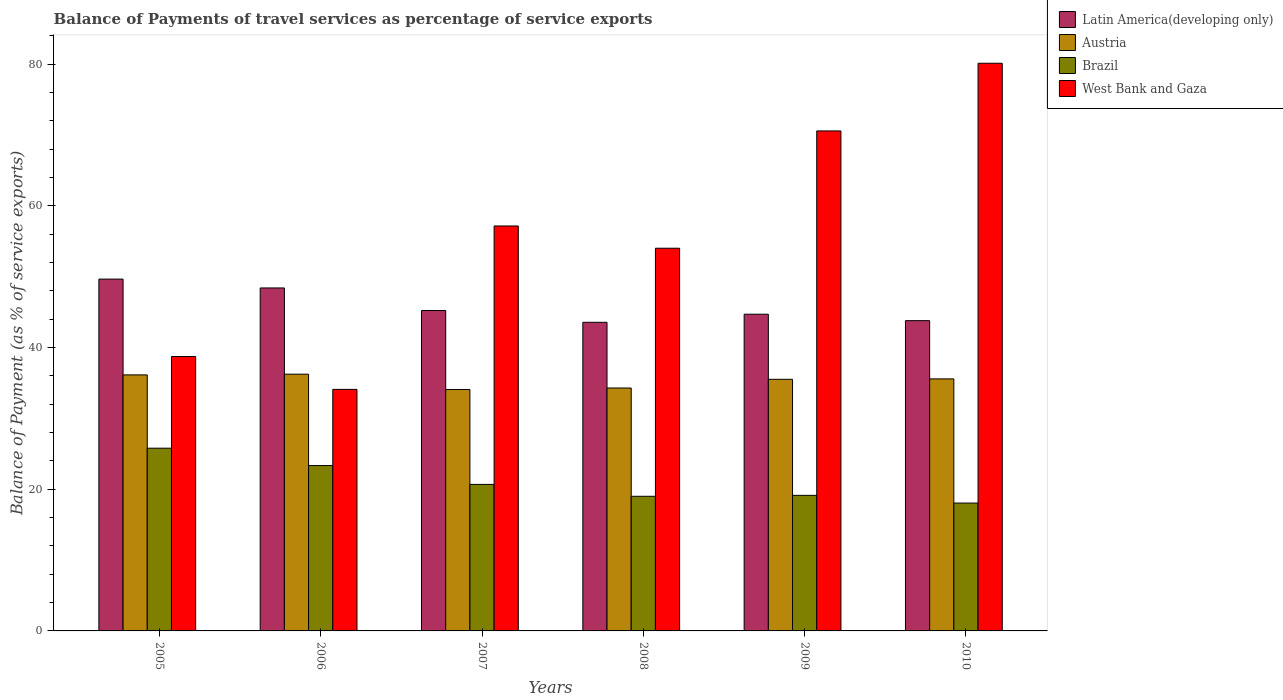How many different coloured bars are there?
Ensure brevity in your answer.  4. How many groups of bars are there?
Keep it short and to the point. 6. How many bars are there on the 3rd tick from the left?
Your response must be concise. 4. How many bars are there on the 5th tick from the right?
Keep it short and to the point. 4. What is the balance of payments of travel services in West Bank and Gaza in 2009?
Offer a terse response. 70.56. Across all years, what is the maximum balance of payments of travel services in Brazil?
Make the answer very short. 25.78. Across all years, what is the minimum balance of payments of travel services in Brazil?
Your answer should be very brief. 18.04. In which year was the balance of payments of travel services in Austria maximum?
Give a very brief answer. 2006. What is the total balance of payments of travel services in Austria in the graph?
Provide a short and direct response. 211.78. What is the difference between the balance of payments of travel services in Latin America(developing only) in 2006 and that in 2010?
Give a very brief answer. 4.61. What is the difference between the balance of payments of travel services in West Bank and Gaza in 2007 and the balance of payments of travel services in Brazil in 2010?
Provide a succinct answer. 39.1. What is the average balance of payments of travel services in West Bank and Gaza per year?
Ensure brevity in your answer.  55.77. In the year 2006, what is the difference between the balance of payments of travel services in West Bank and Gaza and balance of payments of travel services in Austria?
Offer a very short reply. -2.14. What is the ratio of the balance of payments of travel services in Latin America(developing only) in 2005 to that in 2010?
Your answer should be compact. 1.13. Is the balance of payments of travel services in Brazil in 2006 less than that in 2008?
Make the answer very short. No. Is the difference between the balance of payments of travel services in West Bank and Gaza in 2008 and 2009 greater than the difference between the balance of payments of travel services in Austria in 2008 and 2009?
Your response must be concise. No. What is the difference between the highest and the second highest balance of payments of travel services in Brazil?
Provide a short and direct response. 2.45. What is the difference between the highest and the lowest balance of payments of travel services in Austria?
Your answer should be compact. 2.16. What does the 3rd bar from the left in 2010 represents?
Offer a terse response. Brazil. What does the 1st bar from the right in 2007 represents?
Provide a succinct answer. West Bank and Gaza. Is it the case that in every year, the sum of the balance of payments of travel services in Latin America(developing only) and balance of payments of travel services in Brazil is greater than the balance of payments of travel services in West Bank and Gaza?
Give a very brief answer. No. How many bars are there?
Keep it short and to the point. 24. Are all the bars in the graph horizontal?
Offer a very short reply. No. How many years are there in the graph?
Offer a very short reply. 6. Are the values on the major ticks of Y-axis written in scientific E-notation?
Make the answer very short. No. Does the graph contain any zero values?
Provide a succinct answer. No. Does the graph contain grids?
Give a very brief answer. No. Where does the legend appear in the graph?
Your answer should be very brief. Top right. How many legend labels are there?
Provide a short and direct response. 4. How are the legend labels stacked?
Provide a succinct answer. Vertical. What is the title of the graph?
Provide a short and direct response. Balance of Payments of travel services as percentage of service exports. What is the label or title of the X-axis?
Provide a short and direct response. Years. What is the label or title of the Y-axis?
Your answer should be very brief. Balance of Payment (as % of service exports). What is the Balance of Payment (as % of service exports) of Latin America(developing only) in 2005?
Give a very brief answer. 49.65. What is the Balance of Payment (as % of service exports) in Austria in 2005?
Give a very brief answer. 36.13. What is the Balance of Payment (as % of service exports) in Brazil in 2005?
Ensure brevity in your answer.  25.78. What is the Balance of Payment (as % of service exports) in West Bank and Gaza in 2005?
Your answer should be very brief. 38.72. What is the Balance of Payment (as % of service exports) in Latin America(developing only) in 2006?
Provide a short and direct response. 48.4. What is the Balance of Payment (as % of service exports) of Austria in 2006?
Offer a very short reply. 36.23. What is the Balance of Payment (as % of service exports) of Brazil in 2006?
Provide a succinct answer. 23.34. What is the Balance of Payment (as % of service exports) of West Bank and Gaza in 2006?
Offer a terse response. 34.09. What is the Balance of Payment (as % of service exports) in Latin America(developing only) in 2007?
Provide a short and direct response. 45.22. What is the Balance of Payment (as % of service exports) in Austria in 2007?
Provide a short and direct response. 34.07. What is the Balance of Payment (as % of service exports) in Brazil in 2007?
Ensure brevity in your answer.  20.68. What is the Balance of Payment (as % of service exports) of West Bank and Gaza in 2007?
Ensure brevity in your answer.  57.14. What is the Balance of Payment (as % of service exports) of Latin America(developing only) in 2008?
Offer a very short reply. 43.55. What is the Balance of Payment (as % of service exports) in Austria in 2008?
Offer a terse response. 34.28. What is the Balance of Payment (as % of service exports) of Brazil in 2008?
Your answer should be compact. 19. What is the Balance of Payment (as % of service exports) of West Bank and Gaza in 2008?
Make the answer very short. 54. What is the Balance of Payment (as % of service exports) in Latin America(developing only) in 2009?
Ensure brevity in your answer.  44.69. What is the Balance of Payment (as % of service exports) of Austria in 2009?
Offer a terse response. 35.51. What is the Balance of Payment (as % of service exports) in Brazil in 2009?
Provide a succinct answer. 19.13. What is the Balance of Payment (as % of service exports) in West Bank and Gaza in 2009?
Offer a terse response. 70.56. What is the Balance of Payment (as % of service exports) of Latin America(developing only) in 2010?
Provide a succinct answer. 43.78. What is the Balance of Payment (as % of service exports) of Austria in 2010?
Your answer should be compact. 35.57. What is the Balance of Payment (as % of service exports) in Brazil in 2010?
Keep it short and to the point. 18.04. What is the Balance of Payment (as % of service exports) in West Bank and Gaza in 2010?
Keep it short and to the point. 80.1. Across all years, what is the maximum Balance of Payment (as % of service exports) in Latin America(developing only)?
Make the answer very short. 49.65. Across all years, what is the maximum Balance of Payment (as % of service exports) of Austria?
Your answer should be compact. 36.23. Across all years, what is the maximum Balance of Payment (as % of service exports) of Brazil?
Your answer should be very brief. 25.78. Across all years, what is the maximum Balance of Payment (as % of service exports) of West Bank and Gaza?
Ensure brevity in your answer.  80.1. Across all years, what is the minimum Balance of Payment (as % of service exports) in Latin America(developing only)?
Provide a short and direct response. 43.55. Across all years, what is the minimum Balance of Payment (as % of service exports) of Austria?
Your response must be concise. 34.07. Across all years, what is the minimum Balance of Payment (as % of service exports) in Brazil?
Your answer should be very brief. 18.04. Across all years, what is the minimum Balance of Payment (as % of service exports) in West Bank and Gaza?
Keep it short and to the point. 34.09. What is the total Balance of Payment (as % of service exports) of Latin America(developing only) in the graph?
Your answer should be very brief. 275.29. What is the total Balance of Payment (as % of service exports) in Austria in the graph?
Provide a short and direct response. 211.78. What is the total Balance of Payment (as % of service exports) in Brazil in the graph?
Give a very brief answer. 125.97. What is the total Balance of Payment (as % of service exports) of West Bank and Gaza in the graph?
Make the answer very short. 334.61. What is the difference between the Balance of Payment (as % of service exports) of Latin America(developing only) in 2005 and that in 2006?
Provide a succinct answer. 1.25. What is the difference between the Balance of Payment (as % of service exports) of Austria in 2005 and that in 2006?
Keep it short and to the point. -0.1. What is the difference between the Balance of Payment (as % of service exports) in Brazil in 2005 and that in 2006?
Provide a succinct answer. 2.45. What is the difference between the Balance of Payment (as % of service exports) of West Bank and Gaza in 2005 and that in 2006?
Keep it short and to the point. 4.63. What is the difference between the Balance of Payment (as % of service exports) in Latin America(developing only) in 2005 and that in 2007?
Ensure brevity in your answer.  4.43. What is the difference between the Balance of Payment (as % of service exports) in Austria in 2005 and that in 2007?
Provide a succinct answer. 2.06. What is the difference between the Balance of Payment (as % of service exports) in Brazil in 2005 and that in 2007?
Your response must be concise. 5.11. What is the difference between the Balance of Payment (as % of service exports) in West Bank and Gaza in 2005 and that in 2007?
Your response must be concise. -18.43. What is the difference between the Balance of Payment (as % of service exports) of Latin America(developing only) in 2005 and that in 2008?
Keep it short and to the point. 6.1. What is the difference between the Balance of Payment (as % of service exports) of Austria in 2005 and that in 2008?
Keep it short and to the point. 1.85. What is the difference between the Balance of Payment (as % of service exports) in Brazil in 2005 and that in 2008?
Give a very brief answer. 6.79. What is the difference between the Balance of Payment (as % of service exports) of West Bank and Gaza in 2005 and that in 2008?
Offer a terse response. -15.29. What is the difference between the Balance of Payment (as % of service exports) of Latin America(developing only) in 2005 and that in 2009?
Ensure brevity in your answer.  4.96. What is the difference between the Balance of Payment (as % of service exports) in Austria in 2005 and that in 2009?
Offer a very short reply. 0.62. What is the difference between the Balance of Payment (as % of service exports) in Brazil in 2005 and that in 2009?
Keep it short and to the point. 6.65. What is the difference between the Balance of Payment (as % of service exports) in West Bank and Gaza in 2005 and that in 2009?
Give a very brief answer. -31.84. What is the difference between the Balance of Payment (as % of service exports) of Latin America(developing only) in 2005 and that in 2010?
Offer a terse response. 5.86. What is the difference between the Balance of Payment (as % of service exports) in Austria in 2005 and that in 2010?
Your response must be concise. 0.56. What is the difference between the Balance of Payment (as % of service exports) in Brazil in 2005 and that in 2010?
Keep it short and to the point. 7.74. What is the difference between the Balance of Payment (as % of service exports) of West Bank and Gaza in 2005 and that in 2010?
Offer a very short reply. -41.39. What is the difference between the Balance of Payment (as % of service exports) in Latin America(developing only) in 2006 and that in 2007?
Ensure brevity in your answer.  3.18. What is the difference between the Balance of Payment (as % of service exports) of Austria in 2006 and that in 2007?
Provide a short and direct response. 2.16. What is the difference between the Balance of Payment (as % of service exports) of Brazil in 2006 and that in 2007?
Your answer should be compact. 2.66. What is the difference between the Balance of Payment (as % of service exports) of West Bank and Gaza in 2006 and that in 2007?
Your answer should be very brief. -23.06. What is the difference between the Balance of Payment (as % of service exports) in Latin America(developing only) in 2006 and that in 2008?
Your answer should be compact. 4.85. What is the difference between the Balance of Payment (as % of service exports) in Austria in 2006 and that in 2008?
Give a very brief answer. 1.95. What is the difference between the Balance of Payment (as % of service exports) of Brazil in 2006 and that in 2008?
Offer a very short reply. 4.34. What is the difference between the Balance of Payment (as % of service exports) in West Bank and Gaza in 2006 and that in 2008?
Make the answer very short. -19.92. What is the difference between the Balance of Payment (as % of service exports) in Latin America(developing only) in 2006 and that in 2009?
Provide a succinct answer. 3.71. What is the difference between the Balance of Payment (as % of service exports) of Austria in 2006 and that in 2009?
Make the answer very short. 0.72. What is the difference between the Balance of Payment (as % of service exports) in Brazil in 2006 and that in 2009?
Offer a terse response. 4.2. What is the difference between the Balance of Payment (as % of service exports) in West Bank and Gaza in 2006 and that in 2009?
Your response must be concise. -36.47. What is the difference between the Balance of Payment (as % of service exports) of Latin America(developing only) in 2006 and that in 2010?
Your answer should be very brief. 4.61. What is the difference between the Balance of Payment (as % of service exports) of Austria in 2006 and that in 2010?
Give a very brief answer. 0.66. What is the difference between the Balance of Payment (as % of service exports) in Brazil in 2006 and that in 2010?
Provide a short and direct response. 5.29. What is the difference between the Balance of Payment (as % of service exports) in West Bank and Gaza in 2006 and that in 2010?
Provide a short and direct response. -46.02. What is the difference between the Balance of Payment (as % of service exports) in Latin America(developing only) in 2007 and that in 2008?
Provide a short and direct response. 1.67. What is the difference between the Balance of Payment (as % of service exports) in Austria in 2007 and that in 2008?
Provide a short and direct response. -0.21. What is the difference between the Balance of Payment (as % of service exports) in Brazil in 2007 and that in 2008?
Your response must be concise. 1.68. What is the difference between the Balance of Payment (as % of service exports) in West Bank and Gaza in 2007 and that in 2008?
Provide a short and direct response. 3.14. What is the difference between the Balance of Payment (as % of service exports) in Latin America(developing only) in 2007 and that in 2009?
Your response must be concise. 0.53. What is the difference between the Balance of Payment (as % of service exports) in Austria in 2007 and that in 2009?
Provide a short and direct response. -1.44. What is the difference between the Balance of Payment (as % of service exports) in Brazil in 2007 and that in 2009?
Make the answer very short. 1.55. What is the difference between the Balance of Payment (as % of service exports) in West Bank and Gaza in 2007 and that in 2009?
Your response must be concise. -13.41. What is the difference between the Balance of Payment (as % of service exports) of Latin America(developing only) in 2007 and that in 2010?
Keep it short and to the point. 1.43. What is the difference between the Balance of Payment (as % of service exports) in Austria in 2007 and that in 2010?
Your answer should be compact. -1.5. What is the difference between the Balance of Payment (as % of service exports) of Brazil in 2007 and that in 2010?
Offer a terse response. 2.63. What is the difference between the Balance of Payment (as % of service exports) in West Bank and Gaza in 2007 and that in 2010?
Offer a very short reply. -22.96. What is the difference between the Balance of Payment (as % of service exports) in Latin America(developing only) in 2008 and that in 2009?
Your answer should be very brief. -1.14. What is the difference between the Balance of Payment (as % of service exports) in Austria in 2008 and that in 2009?
Make the answer very short. -1.23. What is the difference between the Balance of Payment (as % of service exports) of Brazil in 2008 and that in 2009?
Give a very brief answer. -0.13. What is the difference between the Balance of Payment (as % of service exports) in West Bank and Gaza in 2008 and that in 2009?
Offer a very short reply. -16.55. What is the difference between the Balance of Payment (as % of service exports) of Latin America(developing only) in 2008 and that in 2010?
Keep it short and to the point. -0.23. What is the difference between the Balance of Payment (as % of service exports) of Austria in 2008 and that in 2010?
Offer a terse response. -1.29. What is the difference between the Balance of Payment (as % of service exports) in Brazil in 2008 and that in 2010?
Provide a short and direct response. 0.95. What is the difference between the Balance of Payment (as % of service exports) of West Bank and Gaza in 2008 and that in 2010?
Ensure brevity in your answer.  -26.1. What is the difference between the Balance of Payment (as % of service exports) of Latin America(developing only) in 2009 and that in 2010?
Offer a very short reply. 0.91. What is the difference between the Balance of Payment (as % of service exports) in Austria in 2009 and that in 2010?
Your answer should be compact. -0.06. What is the difference between the Balance of Payment (as % of service exports) in Brazil in 2009 and that in 2010?
Your response must be concise. 1.09. What is the difference between the Balance of Payment (as % of service exports) in West Bank and Gaza in 2009 and that in 2010?
Your answer should be very brief. -9.55. What is the difference between the Balance of Payment (as % of service exports) in Latin America(developing only) in 2005 and the Balance of Payment (as % of service exports) in Austria in 2006?
Give a very brief answer. 13.42. What is the difference between the Balance of Payment (as % of service exports) in Latin America(developing only) in 2005 and the Balance of Payment (as % of service exports) in Brazil in 2006?
Provide a short and direct response. 26.31. What is the difference between the Balance of Payment (as % of service exports) of Latin America(developing only) in 2005 and the Balance of Payment (as % of service exports) of West Bank and Gaza in 2006?
Keep it short and to the point. 15.56. What is the difference between the Balance of Payment (as % of service exports) of Austria in 2005 and the Balance of Payment (as % of service exports) of Brazil in 2006?
Give a very brief answer. 12.79. What is the difference between the Balance of Payment (as % of service exports) in Austria in 2005 and the Balance of Payment (as % of service exports) in West Bank and Gaza in 2006?
Provide a succinct answer. 2.04. What is the difference between the Balance of Payment (as % of service exports) of Brazil in 2005 and the Balance of Payment (as % of service exports) of West Bank and Gaza in 2006?
Offer a terse response. -8.3. What is the difference between the Balance of Payment (as % of service exports) in Latin America(developing only) in 2005 and the Balance of Payment (as % of service exports) in Austria in 2007?
Keep it short and to the point. 15.58. What is the difference between the Balance of Payment (as % of service exports) in Latin America(developing only) in 2005 and the Balance of Payment (as % of service exports) in Brazil in 2007?
Ensure brevity in your answer.  28.97. What is the difference between the Balance of Payment (as % of service exports) of Latin America(developing only) in 2005 and the Balance of Payment (as % of service exports) of West Bank and Gaza in 2007?
Ensure brevity in your answer.  -7.5. What is the difference between the Balance of Payment (as % of service exports) in Austria in 2005 and the Balance of Payment (as % of service exports) in Brazil in 2007?
Keep it short and to the point. 15.45. What is the difference between the Balance of Payment (as % of service exports) of Austria in 2005 and the Balance of Payment (as % of service exports) of West Bank and Gaza in 2007?
Give a very brief answer. -21.02. What is the difference between the Balance of Payment (as % of service exports) in Brazil in 2005 and the Balance of Payment (as % of service exports) in West Bank and Gaza in 2007?
Your response must be concise. -31.36. What is the difference between the Balance of Payment (as % of service exports) of Latin America(developing only) in 2005 and the Balance of Payment (as % of service exports) of Austria in 2008?
Give a very brief answer. 15.37. What is the difference between the Balance of Payment (as % of service exports) of Latin America(developing only) in 2005 and the Balance of Payment (as % of service exports) of Brazil in 2008?
Your response must be concise. 30.65. What is the difference between the Balance of Payment (as % of service exports) in Latin America(developing only) in 2005 and the Balance of Payment (as % of service exports) in West Bank and Gaza in 2008?
Make the answer very short. -4.36. What is the difference between the Balance of Payment (as % of service exports) of Austria in 2005 and the Balance of Payment (as % of service exports) of Brazil in 2008?
Make the answer very short. 17.13. What is the difference between the Balance of Payment (as % of service exports) of Austria in 2005 and the Balance of Payment (as % of service exports) of West Bank and Gaza in 2008?
Ensure brevity in your answer.  -17.87. What is the difference between the Balance of Payment (as % of service exports) in Brazil in 2005 and the Balance of Payment (as % of service exports) in West Bank and Gaza in 2008?
Give a very brief answer. -28.22. What is the difference between the Balance of Payment (as % of service exports) in Latin America(developing only) in 2005 and the Balance of Payment (as % of service exports) in Austria in 2009?
Make the answer very short. 14.14. What is the difference between the Balance of Payment (as % of service exports) in Latin America(developing only) in 2005 and the Balance of Payment (as % of service exports) in Brazil in 2009?
Provide a short and direct response. 30.52. What is the difference between the Balance of Payment (as % of service exports) of Latin America(developing only) in 2005 and the Balance of Payment (as % of service exports) of West Bank and Gaza in 2009?
Give a very brief answer. -20.91. What is the difference between the Balance of Payment (as % of service exports) of Austria in 2005 and the Balance of Payment (as % of service exports) of Brazil in 2009?
Keep it short and to the point. 17. What is the difference between the Balance of Payment (as % of service exports) of Austria in 2005 and the Balance of Payment (as % of service exports) of West Bank and Gaza in 2009?
Provide a succinct answer. -34.43. What is the difference between the Balance of Payment (as % of service exports) of Brazil in 2005 and the Balance of Payment (as % of service exports) of West Bank and Gaza in 2009?
Ensure brevity in your answer.  -44.77. What is the difference between the Balance of Payment (as % of service exports) of Latin America(developing only) in 2005 and the Balance of Payment (as % of service exports) of Austria in 2010?
Your answer should be very brief. 14.08. What is the difference between the Balance of Payment (as % of service exports) in Latin America(developing only) in 2005 and the Balance of Payment (as % of service exports) in Brazil in 2010?
Ensure brevity in your answer.  31.6. What is the difference between the Balance of Payment (as % of service exports) of Latin America(developing only) in 2005 and the Balance of Payment (as % of service exports) of West Bank and Gaza in 2010?
Offer a very short reply. -30.46. What is the difference between the Balance of Payment (as % of service exports) in Austria in 2005 and the Balance of Payment (as % of service exports) in Brazil in 2010?
Provide a short and direct response. 18.08. What is the difference between the Balance of Payment (as % of service exports) in Austria in 2005 and the Balance of Payment (as % of service exports) in West Bank and Gaza in 2010?
Offer a very short reply. -43.98. What is the difference between the Balance of Payment (as % of service exports) in Brazil in 2005 and the Balance of Payment (as % of service exports) in West Bank and Gaza in 2010?
Your answer should be compact. -54.32. What is the difference between the Balance of Payment (as % of service exports) in Latin America(developing only) in 2006 and the Balance of Payment (as % of service exports) in Austria in 2007?
Give a very brief answer. 14.33. What is the difference between the Balance of Payment (as % of service exports) in Latin America(developing only) in 2006 and the Balance of Payment (as % of service exports) in Brazil in 2007?
Keep it short and to the point. 27.72. What is the difference between the Balance of Payment (as % of service exports) in Latin America(developing only) in 2006 and the Balance of Payment (as % of service exports) in West Bank and Gaza in 2007?
Ensure brevity in your answer.  -8.75. What is the difference between the Balance of Payment (as % of service exports) of Austria in 2006 and the Balance of Payment (as % of service exports) of Brazil in 2007?
Keep it short and to the point. 15.55. What is the difference between the Balance of Payment (as % of service exports) of Austria in 2006 and the Balance of Payment (as % of service exports) of West Bank and Gaza in 2007?
Keep it short and to the point. -20.91. What is the difference between the Balance of Payment (as % of service exports) of Brazil in 2006 and the Balance of Payment (as % of service exports) of West Bank and Gaza in 2007?
Your answer should be very brief. -33.81. What is the difference between the Balance of Payment (as % of service exports) of Latin America(developing only) in 2006 and the Balance of Payment (as % of service exports) of Austria in 2008?
Offer a terse response. 14.12. What is the difference between the Balance of Payment (as % of service exports) in Latin America(developing only) in 2006 and the Balance of Payment (as % of service exports) in Brazil in 2008?
Your response must be concise. 29.4. What is the difference between the Balance of Payment (as % of service exports) in Latin America(developing only) in 2006 and the Balance of Payment (as % of service exports) in West Bank and Gaza in 2008?
Keep it short and to the point. -5.61. What is the difference between the Balance of Payment (as % of service exports) in Austria in 2006 and the Balance of Payment (as % of service exports) in Brazil in 2008?
Offer a very short reply. 17.23. What is the difference between the Balance of Payment (as % of service exports) in Austria in 2006 and the Balance of Payment (as % of service exports) in West Bank and Gaza in 2008?
Provide a succinct answer. -17.77. What is the difference between the Balance of Payment (as % of service exports) in Brazil in 2006 and the Balance of Payment (as % of service exports) in West Bank and Gaza in 2008?
Ensure brevity in your answer.  -30.67. What is the difference between the Balance of Payment (as % of service exports) of Latin America(developing only) in 2006 and the Balance of Payment (as % of service exports) of Austria in 2009?
Your answer should be very brief. 12.89. What is the difference between the Balance of Payment (as % of service exports) in Latin America(developing only) in 2006 and the Balance of Payment (as % of service exports) in Brazil in 2009?
Provide a short and direct response. 29.27. What is the difference between the Balance of Payment (as % of service exports) of Latin America(developing only) in 2006 and the Balance of Payment (as % of service exports) of West Bank and Gaza in 2009?
Make the answer very short. -22.16. What is the difference between the Balance of Payment (as % of service exports) of Austria in 2006 and the Balance of Payment (as % of service exports) of Brazil in 2009?
Offer a very short reply. 17.1. What is the difference between the Balance of Payment (as % of service exports) of Austria in 2006 and the Balance of Payment (as % of service exports) of West Bank and Gaza in 2009?
Your answer should be very brief. -34.33. What is the difference between the Balance of Payment (as % of service exports) in Brazil in 2006 and the Balance of Payment (as % of service exports) in West Bank and Gaza in 2009?
Provide a succinct answer. -47.22. What is the difference between the Balance of Payment (as % of service exports) in Latin America(developing only) in 2006 and the Balance of Payment (as % of service exports) in Austria in 2010?
Provide a succinct answer. 12.83. What is the difference between the Balance of Payment (as % of service exports) of Latin America(developing only) in 2006 and the Balance of Payment (as % of service exports) of Brazil in 2010?
Give a very brief answer. 30.35. What is the difference between the Balance of Payment (as % of service exports) in Latin America(developing only) in 2006 and the Balance of Payment (as % of service exports) in West Bank and Gaza in 2010?
Give a very brief answer. -31.71. What is the difference between the Balance of Payment (as % of service exports) in Austria in 2006 and the Balance of Payment (as % of service exports) in Brazil in 2010?
Your response must be concise. 18.19. What is the difference between the Balance of Payment (as % of service exports) in Austria in 2006 and the Balance of Payment (as % of service exports) in West Bank and Gaza in 2010?
Keep it short and to the point. -43.88. What is the difference between the Balance of Payment (as % of service exports) in Brazil in 2006 and the Balance of Payment (as % of service exports) in West Bank and Gaza in 2010?
Give a very brief answer. -56.77. What is the difference between the Balance of Payment (as % of service exports) of Latin America(developing only) in 2007 and the Balance of Payment (as % of service exports) of Austria in 2008?
Offer a very short reply. 10.94. What is the difference between the Balance of Payment (as % of service exports) of Latin America(developing only) in 2007 and the Balance of Payment (as % of service exports) of Brazil in 2008?
Keep it short and to the point. 26.22. What is the difference between the Balance of Payment (as % of service exports) in Latin America(developing only) in 2007 and the Balance of Payment (as % of service exports) in West Bank and Gaza in 2008?
Provide a short and direct response. -8.79. What is the difference between the Balance of Payment (as % of service exports) in Austria in 2007 and the Balance of Payment (as % of service exports) in Brazil in 2008?
Provide a short and direct response. 15.07. What is the difference between the Balance of Payment (as % of service exports) of Austria in 2007 and the Balance of Payment (as % of service exports) of West Bank and Gaza in 2008?
Provide a succinct answer. -19.93. What is the difference between the Balance of Payment (as % of service exports) of Brazil in 2007 and the Balance of Payment (as % of service exports) of West Bank and Gaza in 2008?
Your response must be concise. -33.33. What is the difference between the Balance of Payment (as % of service exports) of Latin America(developing only) in 2007 and the Balance of Payment (as % of service exports) of Austria in 2009?
Your answer should be very brief. 9.71. What is the difference between the Balance of Payment (as % of service exports) of Latin America(developing only) in 2007 and the Balance of Payment (as % of service exports) of Brazil in 2009?
Provide a succinct answer. 26.09. What is the difference between the Balance of Payment (as % of service exports) in Latin America(developing only) in 2007 and the Balance of Payment (as % of service exports) in West Bank and Gaza in 2009?
Your answer should be very brief. -25.34. What is the difference between the Balance of Payment (as % of service exports) in Austria in 2007 and the Balance of Payment (as % of service exports) in Brazil in 2009?
Ensure brevity in your answer.  14.94. What is the difference between the Balance of Payment (as % of service exports) in Austria in 2007 and the Balance of Payment (as % of service exports) in West Bank and Gaza in 2009?
Your response must be concise. -36.49. What is the difference between the Balance of Payment (as % of service exports) in Brazil in 2007 and the Balance of Payment (as % of service exports) in West Bank and Gaza in 2009?
Your answer should be compact. -49.88. What is the difference between the Balance of Payment (as % of service exports) in Latin America(developing only) in 2007 and the Balance of Payment (as % of service exports) in Austria in 2010?
Offer a very short reply. 9.65. What is the difference between the Balance of Payment (as % of service exports) of Latin America(developing only) in 2007 and the Balance of Payment (as % of service exports) of Brazil in 2010?
Make the answer very short. 27.17. What is the difference between the Balance of Payment (as % of service exports) in Latin America(developing only) in 2007 and the Balance of Payment (as % of service exports) in West Bank and Gaza in 2010?
Give a very brief answer. -34.89. What is the difference between the Balance of Payment (as % of service exports) of Austria in 2007 and the Balance of Payment (as % of service exports) of Brazil in 2010?
Your answer should be very brief. 16.03. What is the difference between the Balance of Payment (as % of service exports) in Austria in 2007 and the Balance of Payment (as % of service exports) in West Bank and Gaza in 2010?
Make the answer very short. -46.03. What is the difference between the Balance of Payment (as % of service exports) in Brazil in 2007 and the Balance of Payment (as % of service exports) in West Bank and Gaza in 2010?
Provide a short and direct response. -59.43. What is the difference between the Balance of Payment (as % of service exports) of Latin America(developing only) in 2008 and the Balance of Payment (as % of service exports) of Austria in 2009?
Make the answer very short. 8.04. What is the difference between the Balance of Payment (as % of service exports) in Latin America(developing only) in 2008 and the Balance of Payment (as % of service exports) in Brazil in 2009?
Your response must be concise. 24.42. What is the difference between the Balance of Payment (as % of service exports) of Latin America(developing only) in 2008 and the Balance of Payment (as % of service exports) of West Bank and Gaza in 2009?
Provide a short and direct response. -27.01. What is the difference between the Balance of Payment (as % of service exports) of Austria in 2008 and the Balance of Payment (as % of service exports) of Brazil in 2009?
Offer a terse response. 15.15. What is the difference between the Balance of Payment (as % of service exports) of Austria in 2008 and the Balance of Payment (as % of service exports) of West Bank and Gaza in 2009?
Give a very brief answer. -36.28. What is the difference between the Balance of Payment (as % of service exports) of Brazil in 2008 and the Balance of Payment (as % of service exports) of West Bank and Gaza in 2009?
Keep it short and to the point. -51.56. What is the difference between the Balance of Payment (as % of service exports) in Latin America(developing only) in 2008 and the Balance of Payment (as % of service exports) in Austria in 2010?
Provide a short and direct response. 7.98. What is the difference between the Balance of Payment (as % of service exports) of Latin America(developing only) in 2008 and the Balance of Payment (as % of service exports) of Brazil in 2010?
Offer a terse response. 25.51. What is the difference between the Balance of Payment (as % of service exports) in Latin America(developing only) in 2008 and the Balance of Payment (as % of service exports) in West Bank and Gaza in 2010?
Provide a short and direct response. -36.56. What is the difference between the Balance of Payment (as % of service exports) of Austria in 2008 and the Balance of Payment (as % of service exports) of Brazil in 2010?
Offer a very short reply. 16.24. What is the difference between the Balance of Payment (as % of service exports) of Austria in 2008 and the Balance of Payment (as % of service exports) of West Bank and Gaza in 2010?
Your answer should be very brief. -45.83. What is the difference between the Balance of Payment (as % of service exports) of Brazil in 2008 and the Balance of Payment (as % of service exports) of West Bank and Gaza in 2010?
Offer a terse response. -61.11. What is the difference between the Balance of Payment (as % of service exports) of Latin America(developing only) in 2009 and the Balance of Payment (as % of service exports) of Austria in 2010?
Your answer should be compact. 9.13. What is the difference between the Balance of Payment (as % of service exports) in Latin America(developing only) in 2009 and the Balance of Payment (as % of service exports) in Brazil in 2010?
Offer a terse response. 26.65. What is the difference between the Balance of Payment (as % of service exports) in Latin America(developing only) in 2009 and the Balance of Payment (as % of service exports) in West Bank and Gaza in 2010?
Offer a terse response. -35.41. What is the difference between the Balance of Payment (as % of service exports) of Austria in 2009 and the Balance of Payment (as % of service exports) of Brazil in 2010?
Offer a terse response. 17.46. What is the difference between the Balance of Payment (as % of service exports) in Austria in 2009 and the Balance of Payment (as % of service exports) in West Bank and Gaza in 2010?
Ensure brevity in your answer.  -44.6. What is the difference between the Balance of Payment (as % of service exports) in Brazil in 2009 and the Balance of Payment (as % of service exports) in West Bank and Gaza in 2010?
Offer a terse response. -60.97. What is the average Balance of Payment (as % of service exports) of Latin America(developing only) per year?
Your answer should be very brief. 45.88. What is the average Balance of Payment (as % of service exports) of Austria per year?
Ensure brevity in your answer.  35.3. What is the average Balance of Payment (as % of service exports) in Brazil per year?
Your response must be concise. 20.99. What is the average Balance of Payment (as % of service exports) of West Bank and Gaza per year?
Offer a very short reply. 55.77. In the year 2005, what is the difference between the Balance of Payment (as % of service exports) in Latin America(developing only) and Balance of Payment (as % of service exports) in Austria?
Ensure brevity in your answer.  13.52. In the year 2005, what is the difference between the Balance of Payment (as % of service exports) in Latin America(developing only) and Balance of Payment (as % of service exports) in Brazil?
Keep it short and to the point. 23.86. In the year 2005, what is the difference between the Balance of Payment (as % of service exports) in Latin America(developing only) and Balance of Payment (as % of service exports) in West Bank and Gaza?
Provide a short and direct response. 10.93. In the year 2005, what is the difference between the Balance of Payment (as % of service exports) of Austria and Balance of Payment (as % of service exports) of Brazil?
Your answer should be compact. 10.34. In the year 2005, what is the difference between the Balance of Payment (as % of service exports) of Austria and Balance of Payment (as % of service exports) of West Bank and Gaza?
Your response must be concise. -2.59. In the year 2005, what is the difference between the Balance of Payment (as % of service exports) of Brazil and Balance of Payment (as % of service exports) of West Bank and Gaza?
Make the answer very short. -12.93. In the year 2006, what is the difference between the Balance of Payment (as % of service exports) of Latin America(developing only) and Balance of Payment (as % of service exports) of Austria?
Your answer should be very brief. 12.17. In the year 2006, what is the difference between the Balance of Payment (as % of service exports) in Latin America(developing only) and Balance of Payment (as % of service exports) in Brazil?
Your answer should be compact. 25.06. In the year 2006, what is the difference between the Balance of Payment (as % of service exports) in Latin America(developing only) and Balance of Payment (as % of service exports) in West Bank and Gaza?
Keep it short and to the point. 14.31. In the year 2006, what is the difference between the Balance of Payment (as % of service exports) of Austria and Balance of Payment (as % of service exports) of Brazil?
Offer a terse response. 12.89. In the year 2006, what is the difference between the Balance of Payment (as % of service exports) of Austria and Balance of Payment (as % of service exports) of West Bank and Gaza?
Your response must be concise. 2.14. In the year 2006, what is the difference between the Balance of Payment (as % of service exports) of Brazil and Balance of Payment (as % of service exports) of West Bank and Gaza?
Keep it short and to the point. -10.75. In the year 2007, what is the difference between the Balance of Payment (as % of service exports) in Latin America(developing only) and Balance of Payment (as % of service exports) in Austria?
Offer a very short reply. 11.15. In the year 2007, what is the difference between the Balance of Payment (as % of service exports) of Latin America(developing only) and Balance of Payment (as % of service exports) of Brazil?
Your answer should be very brief. 24.54. In the year 2007, what is the difference between the Balance of Payment (as % of service exports) of Latin America(developing only) and Balance of Payment (as % of service exports) of West Bank and Gaza?
Your answer should be very brief. -11.93. In the year 2007, what is the difference between the Balance of Payment (as % of service exports) in Austria and Balance of Payment (as % of service exports) in Brazil?
Give a very brief answer. 13.39. In the year 2007, what is the difference between the Balance of Payment (as % of service exports) of Austria and Balance of Payment (as % of service exports) of West Bank and Gaza?
Provide a short and direct response. -23.07. In the year 2007, what is the difference between the Balance of Payment (as % of service exports) in Brazil and Balance of Payment (as % of service exports) in West Bank and Gaza?
Offer a terse response. -36.47. In the year 2008, what is the difference between the Balance of Payment (as % of service exports) in Latin America(developing only) and Balance of Payment (as % of service exports) in Austria?
Give a very brief answer. 9.27. In the year 2008, what is the difference between the Balance of Payment (as % of service exports) in Latin America(developing only) and Balance of Payment (as % of service exports) in Brazil?
Your answer should be compact. 24.55. In the year 2008, what is the difference between the Balance of Payment (as % of service exports) in Latin America(developing only) and Balance of Payment (as % of service exports) in West Bank and Gaza?
Make the answer very short. -10.45. In the year 2008, what is the difference between the Balance of Payment (as % of service exports) in Austria and Balance of Payment (as % of service exports) in Brazil?
Your answer should be compact. 15.28. In the year 2008, what is the difference between the Balance of Payment (as % of service exports) in Austria and Balance of Payment (as % of service exports) in West Bank and Gaza?
Provide a succinct answer. -19.72. In the year 2008, what is the difference between the Balance of Payment (as % of service exports) in Brazil and Balance of Payment (as % of service exports) in West Bank and Gaza?
Keep it short and to the point. -35. In the year 2009, what is the difference between the Balance of Payment (as % of service exports) in Latin America(developing only) and Balance of Payment (as % of service exports) in Austria?
Provide a succinct answer. 9.18. In the year 2009, what is the difference between the Balance of Payment (as % of service exports) of Latin America(developing only) and Balance of Payment (as % of service exports) of Brazil?
Your response must be concise. 25.56. In the year 2009, what is the difference between the Balance of Payment (as % of service exports) in Latin America(developing only) and Balance of Payment (as % of service exports) in West Bank and Gaza?
Provide a short and direct response. -25.86. In the year 2009, what is the difference between the Balance of Payment (as % of service exports) in Austria and Balance of Payment (as % of service exports) in Brazil?
Keep it short and to the point. 16.38. In the year 2009, what is the difference between the Balance of Payment (as % of service exports) of Austria and Balance of Payment (as % of service exports) of West Bank and Gaza?
Keep it short and to the point. -35.05. In the year 2009, what is the difference between the Balance of Payment (as % of service exports) in Brazil and Balance of Payment (as % of service exports) in West Bank and Gaza?
Give a very brief answer. -51.43. In the year 2010, what is the difference between the Balance of Payment (as % of service exports) in Latin America(developing only) and Balance of Payment (as % of service exports) in Austria?
Offer a very short reply. 8.22. In the year 2010, what is the difference between the Balance of Payment (as % of service exports) in Latin America(developing only) and Balance of Payment (as % of service exports) in Brazil?
Make the answer very short. 25.74. In the year 2010, what is the difference between the Balance of Payment (as % of service exports) of Latin America(developing only) and Balance of Payment (as % of service exports) of West Bank and Gaza?
Ensure brevity in your answer.  -36.32. In the year 2010, what is the difference between the Balance of Payment (as % of service exports) of Austria and Balance of Payment (as % of service exports) of Brazil?
Make the answer very short. 17.52. In the year 2010, what is the difference between the Balance of Payment (as % of service exports) in Austria and Balance of Payment (as % of service exports) in West Bank and Gaza?
Make the answer very short. -44.54. In the year 2010, what is the difference between the Balance of Payment (as % of service exports) of Brazil and Balance of Payment (as % of service exports) of West Bank and Gaza?
Offer a very short reply. -62.06. What is the ratio of the Balance of Payment (as % of service exports) of Latin America(developing only) in 2005 to that in 2006?
Keep it short and to the point. 1.03. What is the ratio of the Balance of Payment (as % of service exports) of Brazil in 2005 to that in 2006?
Provide a short and direct response. 1.1. What is the ratio of the Balance of Payment (as % of service exports) of West Bank and Gaza in 2005 to that in 2006?
Provide a succinct answer. 1.14. What is the ratio of the Balance of Payment (as % of service exports) in Latin America(developing only) in 2005 to that in 2007?
Ensure brevity in your answer.  1.1. What is the ratio of the Balance of Payment (as % of service exports) of Austria in 2005 to that in 2007?
Keep it short and to the point. 1.06. What is the ratio of the Balance of Payment (as % of service exports) of Brazil in 2005 to that in 2007?
Offer a very short reply. 1.25. What is the ratio of the Balance of Payment (as % of service exports) of West Bank and Gaza in 2005 to that in 2007?
Make the answer very short. 0.68. What is the ratio of the Balance of Payment (as % of service exports) of Latin America(developing only) in 2005 to that in 2008?
Provide a short and direct response. 1.14. What is the ratio of the Balance of Payment (as % of service exports) in Austria in 2005 to that in 2008?
Provide a short and direct response. 1.05. What is the ratio of the Balance of Payment (as % of service exports) in Brazil in 2005 to that in 2008?
Your response must be concise. 1.36. What is the ratio of the Balance of Payment (as % of service exports) of West Bank and Gaza in 2005 to that in 2008?
Offer a terse response. 0.72. What is the ratio of the Balance of Payment (as % of service exports) in Latin America(developing only) in 2005 to that in 2009?
Your answer should be compact. 1.11. What is the ratio of the Balance of Payment (as % of service exports) in Austria in 2005 to that in 2009?
Give a very brief answer. 1.02. What is the ratio of the Balance of Payment (as % of service exports) in Brazil in 2005 to that in 2009?
Offer a terse response. 1.35. What is the ratio of the Balance of Payment (as % of service exports) in West Bank and Gaza in 2005 to that in 2009?
Provide a succinct answer. 0.55. What is the ratio of the Balance of Payment (as % of service exports) of Latin America(developing only) in 2005 to that in 2010?
Make the answer very short. 1.13. What is the ratio of the Balance of Payment (as % of service exports) in Austria in 2005 to that in 2010?
Keep it short and to the point. 1.02. What is the ratio of the Balance of Payment (as % of service exports) in Brazil in 2005 to that in 2010?
Provide a succinct answer. 1.43. What is the ratio of the Balance of Payment (as % of service exports) in West Bank and Gaza in 2005 to that in 2010?
Make the answer very short. 0.48. What is the ratio of the Balance of Payment (as % of service exports) of Latin America(developing only) in 2006 to that in 2007?
Offer a terse response. 1.07. What is the ratio of the Balance of Payment (as % of service exports) of Austria in 2006 to that in 2007?
Ensure brevity in your answer.  1.06. What is the ratio of the Balance of Payment (as % of service exports) of Brazil in 2006 to that in 2007?
Keep it short and to the point. 1.13. What is the ratio of the Balance of Payment (as % of service exports) of West Bank and Gaza in 2006 to that in 2007?
Offer a terse response. 0.6. What is the ratio of the Balance of Payment (as % of service exports) in Latin America(developing only) in 2006 to that in 2008?
Ensure brevity in your answer.  1.11. What is the ratio of the Balance of Payment (as % of service exports) in Austria in 2006 to that in 2008?
Your answer should be compact. 1.06. What is the ratio of the Balance of Payment (as % of service exports) of Brazil in 2006 to that in 2008?
Provide a succinct answer. 1.23. What is the ratio of the Balance of Payment (as % of service exports) in West Bank and Gaza in 2006 to that in 2008?
Your response must be concise. 0.63. What is the ratio of the Balance of Payment (as % of service exports) in Latin America(developing only) in 2006 to that in 2009?
Give a very brief answer. 1.08. What is the ratio of the Balance of Payment (as % of service exports) in Austria in 2006 to that in 2009?
Your response must be concise. 1.02. What is the ratio of the Balance of Payment (as % of service exports) of Brazil in 2006 to that in 2009?
Offer a terse response. 1.22. What is the ratio of the Balance of Payment (as % of service exports) of West Bank and Gaza in 2006 to that in 2009?
Offer a very short reply. 0.48. What is the ratio of the Balance of Payment (as % of service exports) of Latin America(developing only) in 2006 to that in 2010?
Give a very brief answer. 1.11. What is the ratio of the Balance of Payment (as % of service exports) of Austria in 2006 to that in 2010?
Keep it short and to the point. 1.02. What is the ratio of the Balance of Payment (as % of service exports) of Brazil in 2006 to that in 2010?
Offer a very short reply. 1.29. What is the ratio of the Balance of Payment (as % of service exports) in West Bank and Gaza in 2006 to that in 2010?
Provide a short and direct response. 0.43. What is the ratio of the Balance of Payment (as % of service exports) of Latin America(developing only) in 2007 to that in 2008?
Your response must be concise. 1.04. What is the ratio of the Balance of Payment (as % of service exports) of Austria in 2007 to that in 2008?
Give a very brief answer. 0.99. What is the ratio of the Balance of Payment (as % of service exports) in Brazil in 2007 to that in 2008?
Offer a terse response. 1.09. What is the ratio of the Balance of Payment (as % of service exports) of West Bank and Gaza in 2007 to that in 2008?
Offer a very short reply. 1.06. What is the ratio of the Balance of Payment (as % of service exports) of Latin America(developing only) in 2007 to that in 2009?
Your response must be concise. 1.01. What is the ratio of the Balance of Payment (as % of service exports) of Austria in 2007 to that in 2009?
Provide a short and direct response. 0.96. What is the ratio of the Balance of Payment (as % of service exports) of Brazil in 2007 to that in 2009?
Provide a succinct answer. 1.08. What is the ratio of the Balance of Payment (as % of service exports) in West Bank and Gaza in 2007 to that in 2009?
Provide a succinct answer. 0.81. What is the ratio of the Balance of Payment (as % of service exports) in Latin America(developing only) in 2007 to that in 2010?
Give a very brief answer. 1.03. What is the ratio of the Balance of Payment (as % of service exports) in Austria in 2007 to that in 2010?
Keep it short and to the point. 0.96. What is the ratio of the Balance of Payment (as % of service exports) of Brazil in 2007 to that in 2010?
Offer a very short reply. 1.15. What is the ratio of the Balance of Payment (as % of service exports) in West Bank and Gaza in 2007 to that in 2010?
Provide a short and direct response. 0.71. What is the ratio of the Balance of Payment (as % of service exports) in Latin America(developing only) in 2008 to that in 2009?
Provide a succinct answer. 0.97. What is the ratio of the Balance of Payment (as % of service exports) of Austria in 2008 to that in 2009?
Ensure brevity in your answer.  0.97. What is the ratio of the Balance of Payment (as % of service exports) in Brazil in 2008 to that in 2009?
Give a very brief answer. 0.99. What is the ratio of the Balance of Payment (as % of service exports) of West Bank and Gaza in 2008 to that in 2009?
Your answer should be very brief. 0.77. What is the ratio of the Balance of Payment (as % of service exports) in Austria in 2008 to that in 2010?
Provide a succinct answer. 0.96. What is the ratio of the Balance of Payment (as % of service exports) in Brazil in 2008 to that in 2010?
Offer a very short reply. 1.05. What is the ratio of the Balance of Payment (as % of service exports) of West Bank and Gaza in 2008 to that in 2010?
Your answer should be compact. 0.67. What is the ratio of the Balance of Payment (as % of service exports) of Latin America(developing only) in 2009 to that in 2010?
Keep it short and to the point. 1.02. What is the ratio of the Balance of Payment (as % of service exports) of Brazil in 2009 to that in 2010?
Your answer should be very brief. 1.06. What is the ratio of the Balance of Payment (as % of service exports) in West Bank and Gaza in 2009 to that in 2010?
Keep it short and to the point. 0.88. What is the difference between the highest and the second highest Balance of Payment (as % of service exports) of Latin America(developing only)?
Offer a very short reply. 1.25. What is the difference between the highest and the second highest Balance of Payment (as % of service exports) in Austria?
Give a very brief answer. 0.1. What is the difference between the highest and the second highest Balance of Payment (as % of service exports) of Brazil?
Ensure brevity in your answer.  2.45. What is the difference between the highest and the second highest Balance of Payment (as % of service exports) in West Bank and Gaza?
Give a very brief answer. 9.55. What is the difference between the highest and the lowest Balance of Payment (as % of service exports) of Latin America(developing only)?
Give a very brief answer. 6.1. What is the difference between the highest and the lowest Balance of Payment (as % of service exports) of Austria?
Your answer should be very brief. 2.16. What is the difference between the highest and the lowest Balance of Payment (as % of service exports) of Brazil?
Give a very brief answer. 7.74. What is the difference between the highest and the lowest Balance of Payment (as % of service exports) in West Bank and Gaza?
Provide a succinct answer. 46.02. 